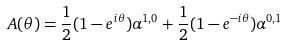Convert formula to latex. <formula><loc_0><loc_0><loc_500><loc_500>A ( { \theta } ) = \frac { 1 } { 2 } ( 1 - e ^ { i \theta } ) \alpha ^ { 1 , 0 } + \frac { 1 } { 2 } ( 1 - e ^ { - i \theta } ) \alpha ^ { 0 , 1 }</formula> 